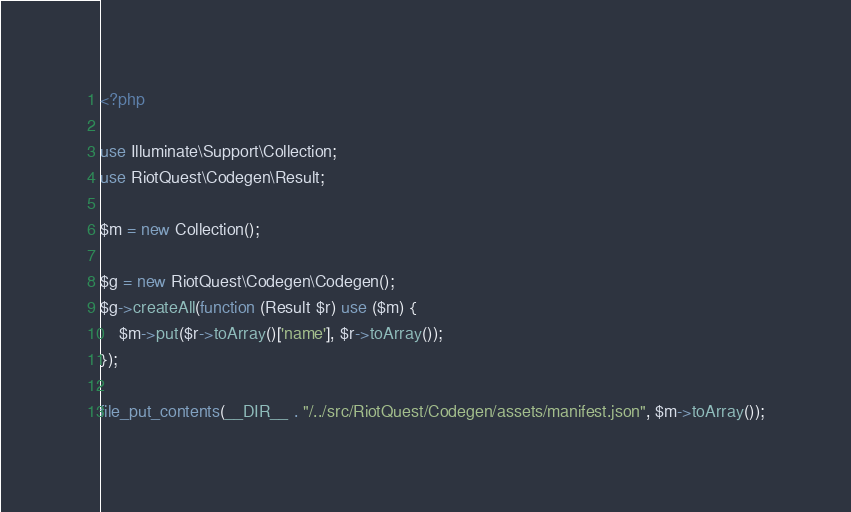<code> <loc_0><loc_0><loc_500><loc_500><_PHP_><?php

use Illuminate\Support\Collection;
use RiotQuest\Codegen\Result;

$m = new Collection();

$g = new RiotQuest\Codegen\Codegen();
$g->createAll(function (Result $r) use ($m) {
    $m->put($r->toArray()['name'], $r->toArray());
});

file_put_contents(__DIR__ . "/../src/RiotQuest/Codegen/assets/manifest.json", $m->toArray());</code> 